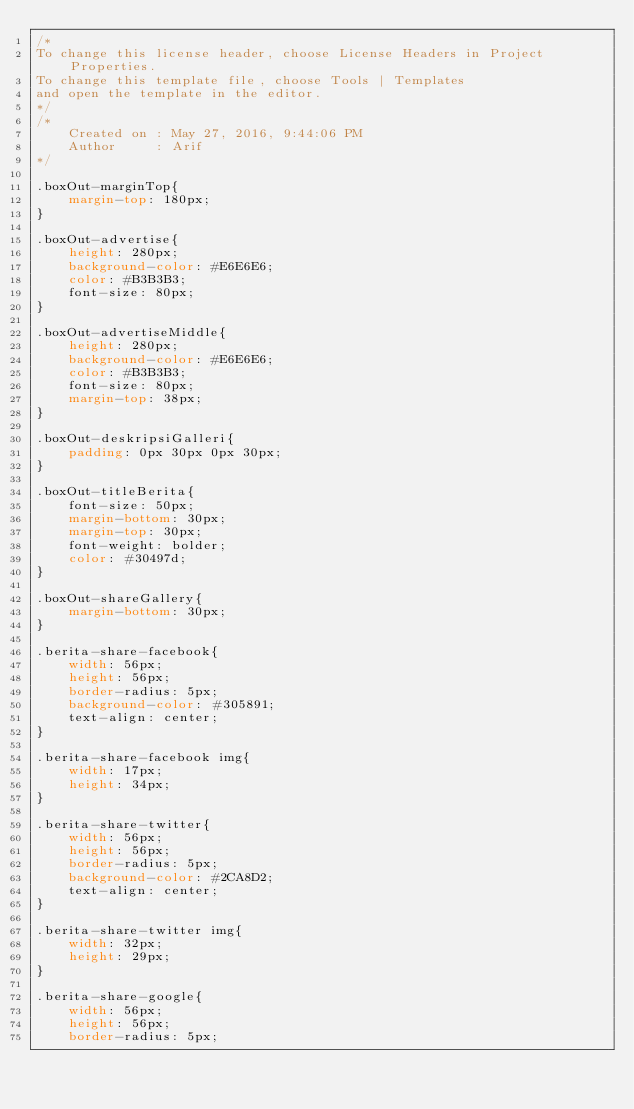<code> <loc_0><loc_0><loc_500><loc_500><_CSS_>/*
To change this license header, choose License Headers in Project Properties.
To change this template file, choose Tools | Templates
and open the template in the editor.
*/
/* 
    Created on : May 27, 2016, 9:44:06 PM
    Author     : Arif
*/

.boxOut-marginTop{
    margin-top: 180px;
}

.boxOut-advertise{
    height: 280px;
    background-color: #E6E6E6;
    color: #B3B3B3;
    font-size: 80px;
}

.boxOut-advertiseMiddle{
    height: 280px;
    background-color: #E6E6E6;
    color: #B3B3B3;
    font-size: 80px;
    margin-top: 38px;
}

.boxOut-deskripsiGalleri{
    padding: 0px 30px 0px 30px;
}

.boxOut-titleBerita{
    font-size: 50px;
    margin-bottom: 30px;
    margin-top: 30px;
    font-weight: bolder;
    color: #30497d;
}

.boxOut-shareGallery{
    margin-bottom: 30px;
}

.berita-share-facebook{
    width: 56px;
    height: 56px;
    border-radius: 5px;
    background-color: #305891;
    text-align: center;
}

.berita-share-facebook img{
    width: 17px;
    height: 34px;
}

.berita-share-twitter{
    width: 56px;
    height: 56px;
    border-radius: 5px;
    background-color: #2CA8D2;
    text-align: center;
}

.berita-share-twitter img{
    width: 32px;
    height: 29px;
}

.berita-share-google{
    width: 56px;
    height: 56px;
    border-radius: 5px;</code> 